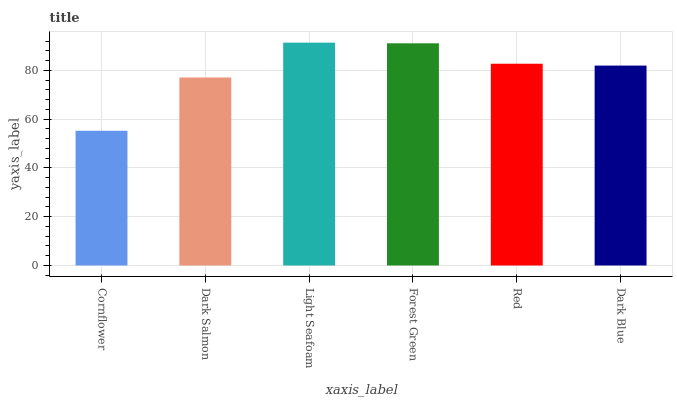Is Cornflower the minimum?
Answer yes or no. Yes. Is Light Seafoam the maximum?
Answer yes or no. Yes. Is Dark Salmon the minimum?
Answer yes or no. No. Is Dark Salmon the maximum?
Answer yes or no. No. Is Dark Salmon greater than Cornflower?
Answer yes or no. Yes. Is Cornflower less than Dark Salmon?
Answer yes or no. Yes. Is Cornflower greater than Dark Salmon?
Answer yes or no. No. Is Dark Salmon less than Cornflower?
Answer yes or no. No. Is Red the high median?
Answer yes or no. Yes. Is Dark Blue the low median?
Answer yes or no. Yes. Is Dark Salmon the high median?
Answer yes or no. No. Is Red the low median?
Answer yes or no. No. 